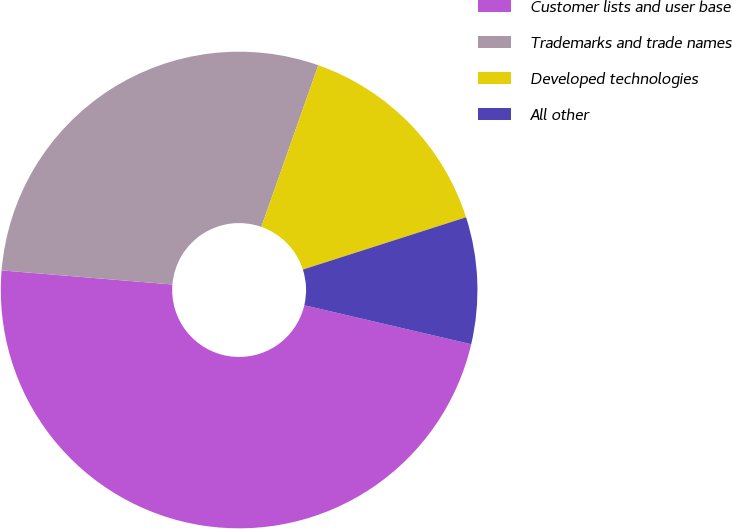Convert chart to OTSL. <chart><loc_0><loc_0><loc_500><loc_500><pie_chart><fcel>Customer lists and user base<fcel>Trademarks and trade names<fcel>Developed technologies<fcel>All other<nl><fcel>47.66%<fcel>29.08%<fcel>14.67%<fcel>8.59%<nl></chart> 